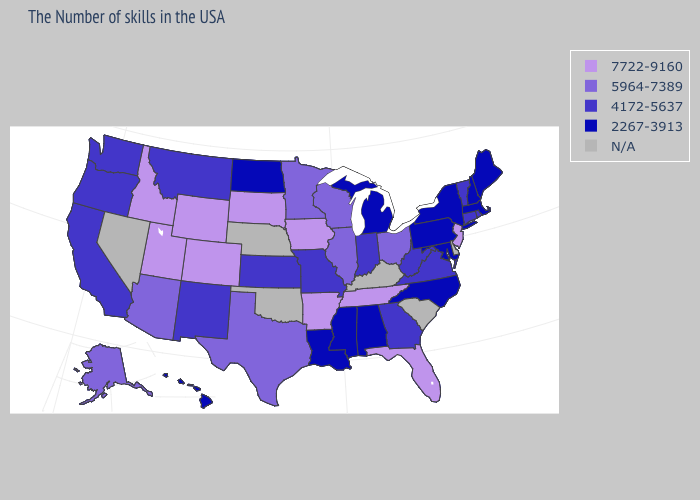What is the value of Vermont?
Short answer required. 4172-5637. Does the first symbol in the legend represent the smallest category?
Short answer required. No. What is the value of Iowa?
Keep it brief. 7722-9160. Which states have the highest value in the USA?
Quick response, please. New Jersey, Florida, Tennessee, Arkansas, Iowa, South Dakota, Wyoming, Colorado, Utah, Idaho. Does Iowa have the highest value in the USA?
Concise answer only. Yes. What is the value of Minnesota?
Give a very brief answer. 5964-7389. Among the states that border Wisconsin , which have the highest value?
Answer briefly. Iowa. Does Louisiana have the highest value in the USA?
Give a very brief answer. No. What is the value of Illinois?
Write a very short answer. 5964-7389. What is the lowest value in the MidWest?
Quick response, please. 2267-3913. Name the states that have a value in the range 7722-9160?
Give a very brief answer. New Jersey, Florida, Tennessee, Arkansas, Iowa, South Dakota, Wyoming, Colorado, Utah, Idaho. What is the value of Louisiana?
Quick response, please. 2267-3913. What is the value of South Dakota?
Keep it brief. 7722-9160. What is the lowest value in states that border Texas?
Be succinct. 2267-3913. 